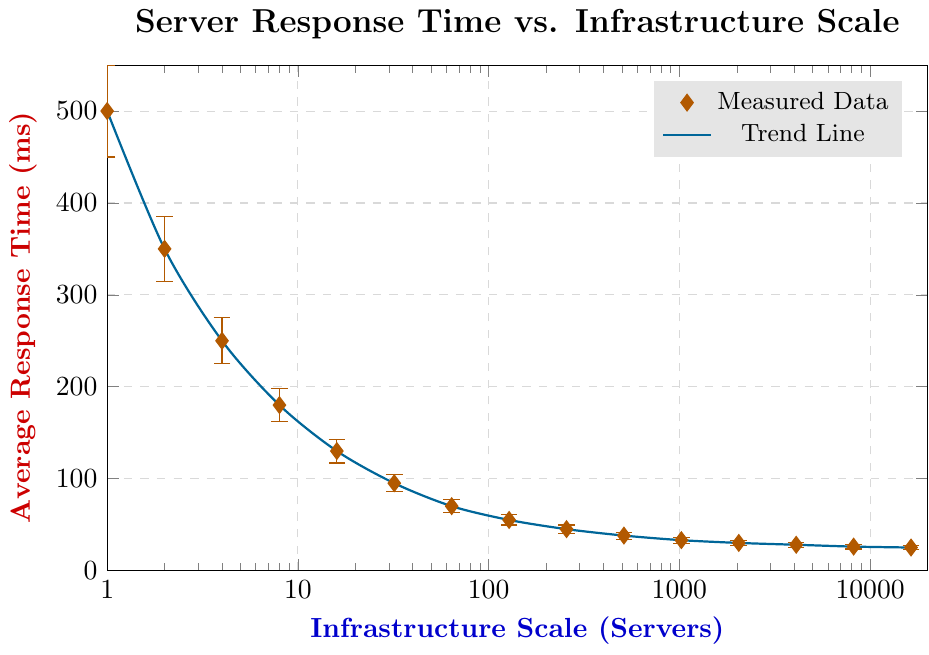What's the highest response time recorded in the figure? Look for the highest data point on the y-axis of the figure, which corresponds to the y-value at the smallest x-value.
Answer: 500 ms How does the response time change as the number of servers increases from 1 to 4? Identify the response times for 1 and 4 servers from the figure, then compare them. For 1 server, the response time is 500 ms, and for 4 servers, it is 250 ms. Calculate the difference.
Answer: Decreases by 250 ms What's the response time difference between 128 servers and 256 servers? Identify the response times for 128 and 256 servers from the figure, then subtract the smaller value from the larger one. For 128 servers, the response time is 55 ms, and for 256 servers, it is 45 ms.
Answer: 10 ms Which server scale shows the lowest average response time? Look for the smallest data point on the y-axis of the figure and identify the corresponding x-value.
Answer: 16384 servers How does the response time trend between 64 and 512 servers? Identify the response times for 64 and 512 servers, then observe the general direction of the trend line between these points in the figure. For 64 servers, the response time is 70 ms, and it gradually decreases to 38 ms for 512 servers.
Answer: Decreases If the response time at 4 servers is 250 ms, what is the percentage reduction in response time when scaled up to 2048 servers? Identify the response times for 4 and 2048 servers from the figure. Response time at 4 servers is 250 ms, and at 2048 servers, it is 30 ms. Use the formula for percentage reduction: ((initial - final) / initial) * 100.
Answer: 88% Is the relationship between server scale and response time linear or non-linear? Observe the trend line connecting the data points in the figure. Since the data is plotted on a logarithmic scale and the decrease in response time is not uniform, the relationship is non-linear.
Answer: Non-linear 